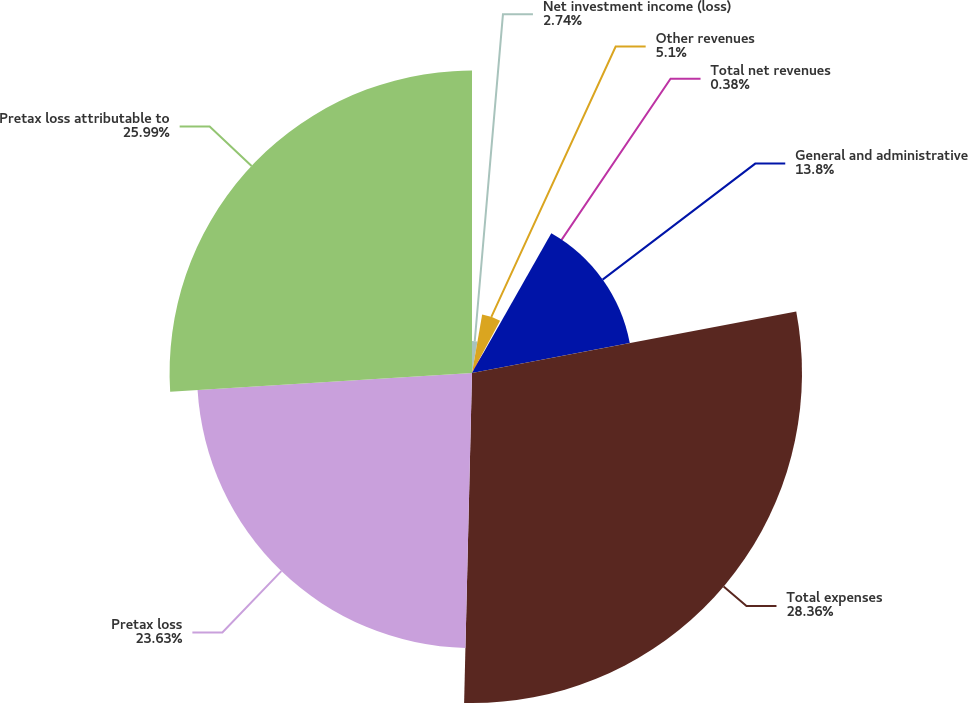Convert chart to OTSL. <chart><loc_0><loc_0><loc_500><loc_500><pie_chart><fcel>Net investment income (loss)<fcel>Other revenues<fcel>Total net revenues<fcel>General and administrative<fcel>Total expenses<fcel>Pretax loss<fcel>Pretax loss attributable to<nl><fcel>2.74%<fcel>5.1%<fcel>0.38%<fcel>13.8%<fcel>28.36%<fcel>23.63%<fcel>25.99%<nl></chart> 